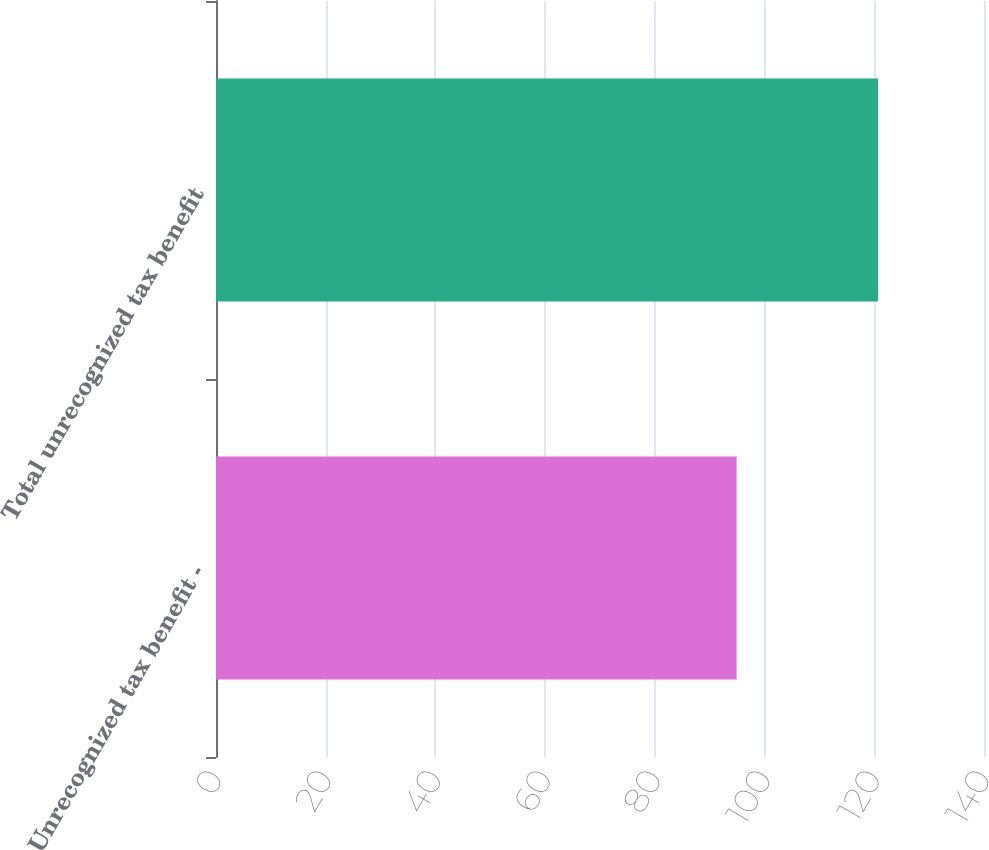Convert chart to OTSL. <chart><loc_0><loc_0><loc_500><loc_500><bar_chart><fcel>Unrecognized tax benefit -<fcel>Total unrecognized tax benefit<nl><fcel>94.9<fcel>120.7<nl></chart> 